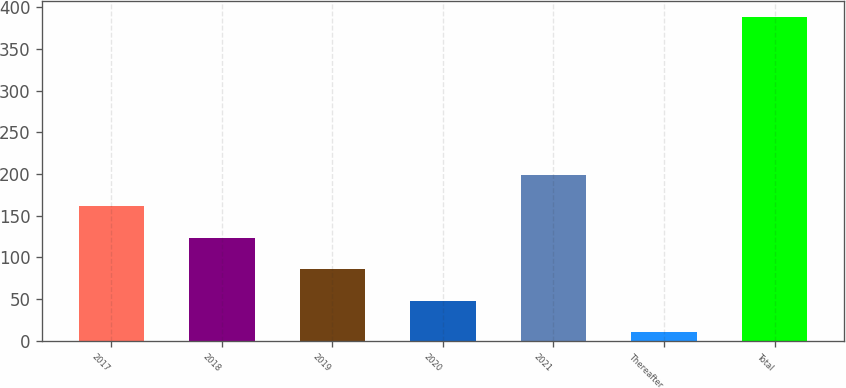Convert chart to OTSL. <chart><loc_0><loc_0><loc_500><loc_500><bar_chart><fcel>2017<fcel>2018<fcel>2019<fcel>2020<fcel>2021<fcel>Thereafter<fcel>Total<nl><fcel>161.2<fcel>123.4<fcel>85.6<fcel>47.8<fcel>199<fcel>10<fcel>388<nl></chart> 